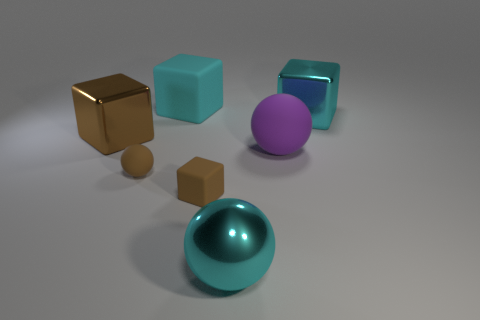How many other objects are there of the same shape as the big purple object?
Provide a succinct answer. 2. There is a big rubber object on the right side of the tiny matte block; is it the same color as the metal block that is left of the purple matte ball?
Keep it short and to the point. No. There is a block left of the ball left of the metallic thing that is in front of the big brown thing; how big is it?
Your answer should be very brief. Large. The thing that is behind the big purple sphere and right of the big metal sphere has what shape?
Your response must be concise. Cube. Are there an equal number of matte cubes right of the small matte block and large purple spheres right of the big matte block?
Your response must be concise. No. Is there a brown cylinder that has the same material as the brown sphere?
Give a very brief answer. No. Are the cyan block that is on the left side of the large purple sphere and the purple thing made of the same material?
Offer a terse response. Yes. What is the size of the metal object that is both to the left of the large purple matte ball and on the right side of the big brown shiny object?
Keep it short and to the point. Large. The tiny cube has what color?
Make the answer very short. Brown. What number of small things are there?
Your response must be concise. 2. 